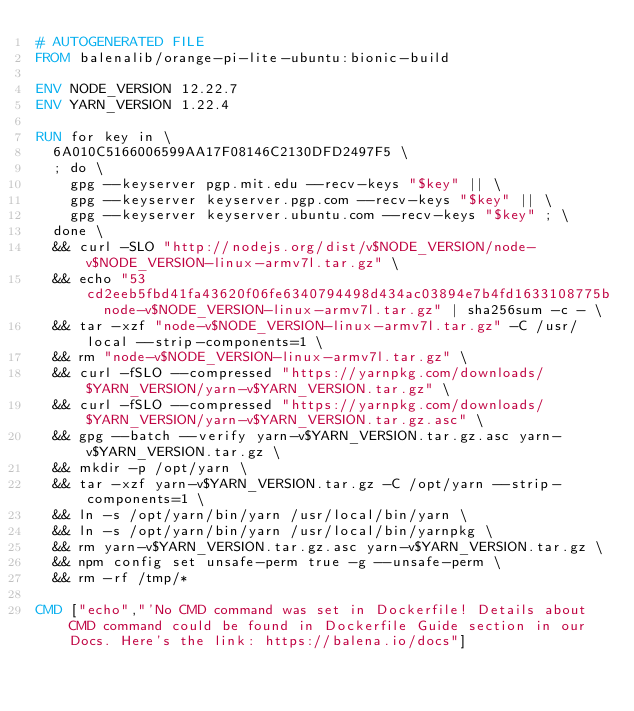<code> <loc_0><loc_0><loc_500><loc_500><_Dockerfile_># AUTOGENERATED FILE
FROM balenalib/orange-pi-lite-ubuntu:bionic-build

ENV NODE_VERSION 12.22.7
ENV YARN_VERSION 1.22.4

RUN for key in \
	6A010C5166006599AA17F08146C2130DFD2497F5 \
	; do \
		gpg --keyserver pgp.mit.edu --recv-keys "$key" || \
		gpg --keyserver keyserver.pgp.com --recv-keys "$key" || \
		gpg --keyserver keyserver.ubuntu.com --recv-keys "$key" ; \
	done \
	&& curl -SLO "http://nodejs.org/dist/v$NODE_VERSION/node-v$NODE_VERSION-linux-armv7l.tar.gz" \
	&& echo "53cd2eeb5fbd41fa43620f06fe6340794498d434ac03894e7b4fd1633108775b  node-v$NODE_VERSION-linux-armv7l.tar.gz" | sha256sum -c - \
	&& tar -xzf "node-v$NODE_VERSION-linux-armv7l.tar.gz" -C /usr/local --strip-components=1 \
	&& rm "node-v$NODE_VERSION-linux-armv7l.tar.gz" \
	&& curl -fSLO --compressed "https://yarnpkg.com/downloads/$YARN_VERSION/yarn-v$YARN_VERSION.tar.gz" \
	&& curl -fSLO --compressed "https://yarnpkg.com/downloads/$YARN_VERSION/yarn-v$YARN_VERSION.tar.gz.asc" \
	&& gpg --batch --verify yarn-v$YARN_VERSION.tar.gz.asc yarn-v$YARN_VERSION.tar.gz \
	&& mkdir -p /opt/yarn \
	&& tar -xzf yarn-v$YARN_VERSION.tar.gz -C /opt/yarn --strip-components=1 \
	&& ln -s /opt/yarn/bin/yarn /usr/local/bin/yarn \
	&& ln -s /opt/yarn/bin/yarn /usr/local/bin/yarnpkg \
	&& rm yarn-v$YARN_VERSION.tar.gz.asc yarn-v$YARN_VERSION.tar.gz \
	&& npm config set unsafe-perm true -g --unsafe-perm \
	&& rm -rf /tmp/*

CMD ["echo","'No CMD command was set in Dockerfile! Details about CMD command could be found in Dockerfile Guide section in our Docs. Here's the link: https://balena.io/docs"]
</code> 